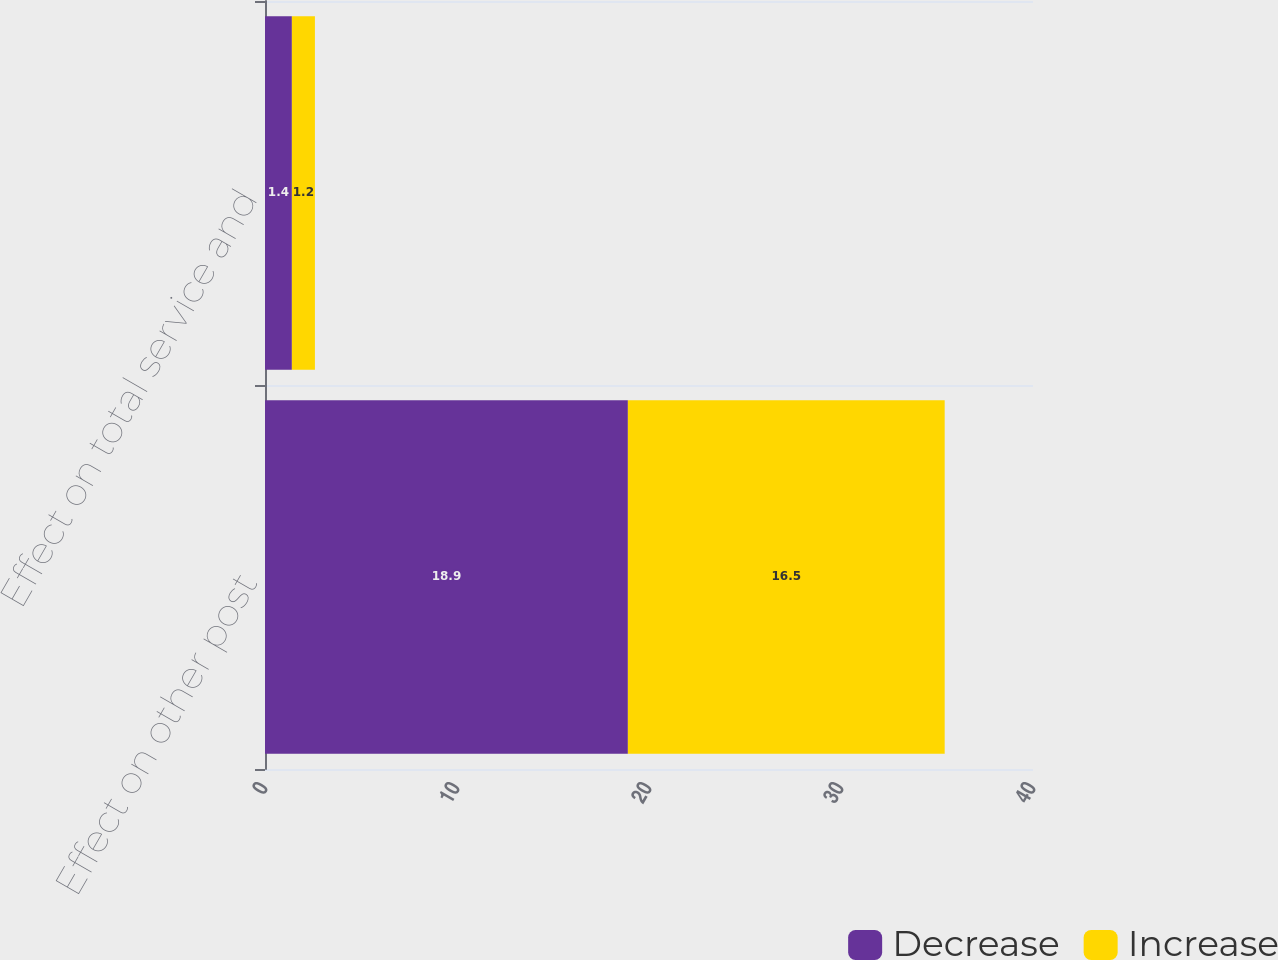<chart> <loc_0><loc_0><loc_500><loc_500><stacked_bar_chart><ecel><fcel>Effect on other post<fcel>Effect on total service and<nl><fcel>Decrease<fcel>18.9<fcel>1.4<nl><fcel>Increase<fcel>16.5<fcel>1.2<nl></chart> 